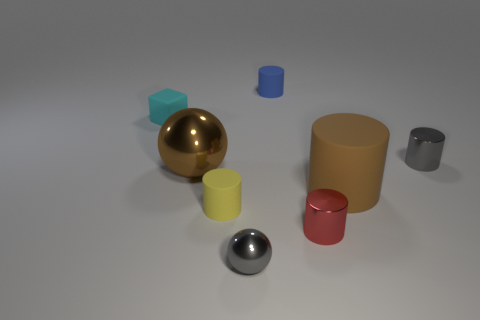Subtract all purple cylinders. Subtract all blue balls. How many cylinders are left? 5 Add 1 cyan cubes. How many objects exist? 9 Subtract all cylinders. How many objects are left? 3 Subtract all big yellow matte objects. Subtract all small cyan blocks. How many objects are left? 7 Add 2 tiny gray metal balls. How many tiny gray metal balls are left? 3 Add 2 large red matte cubes. How many large red matte cubes exist? 2 Subtract 0 yellow cubes. How many objects are left? 8 